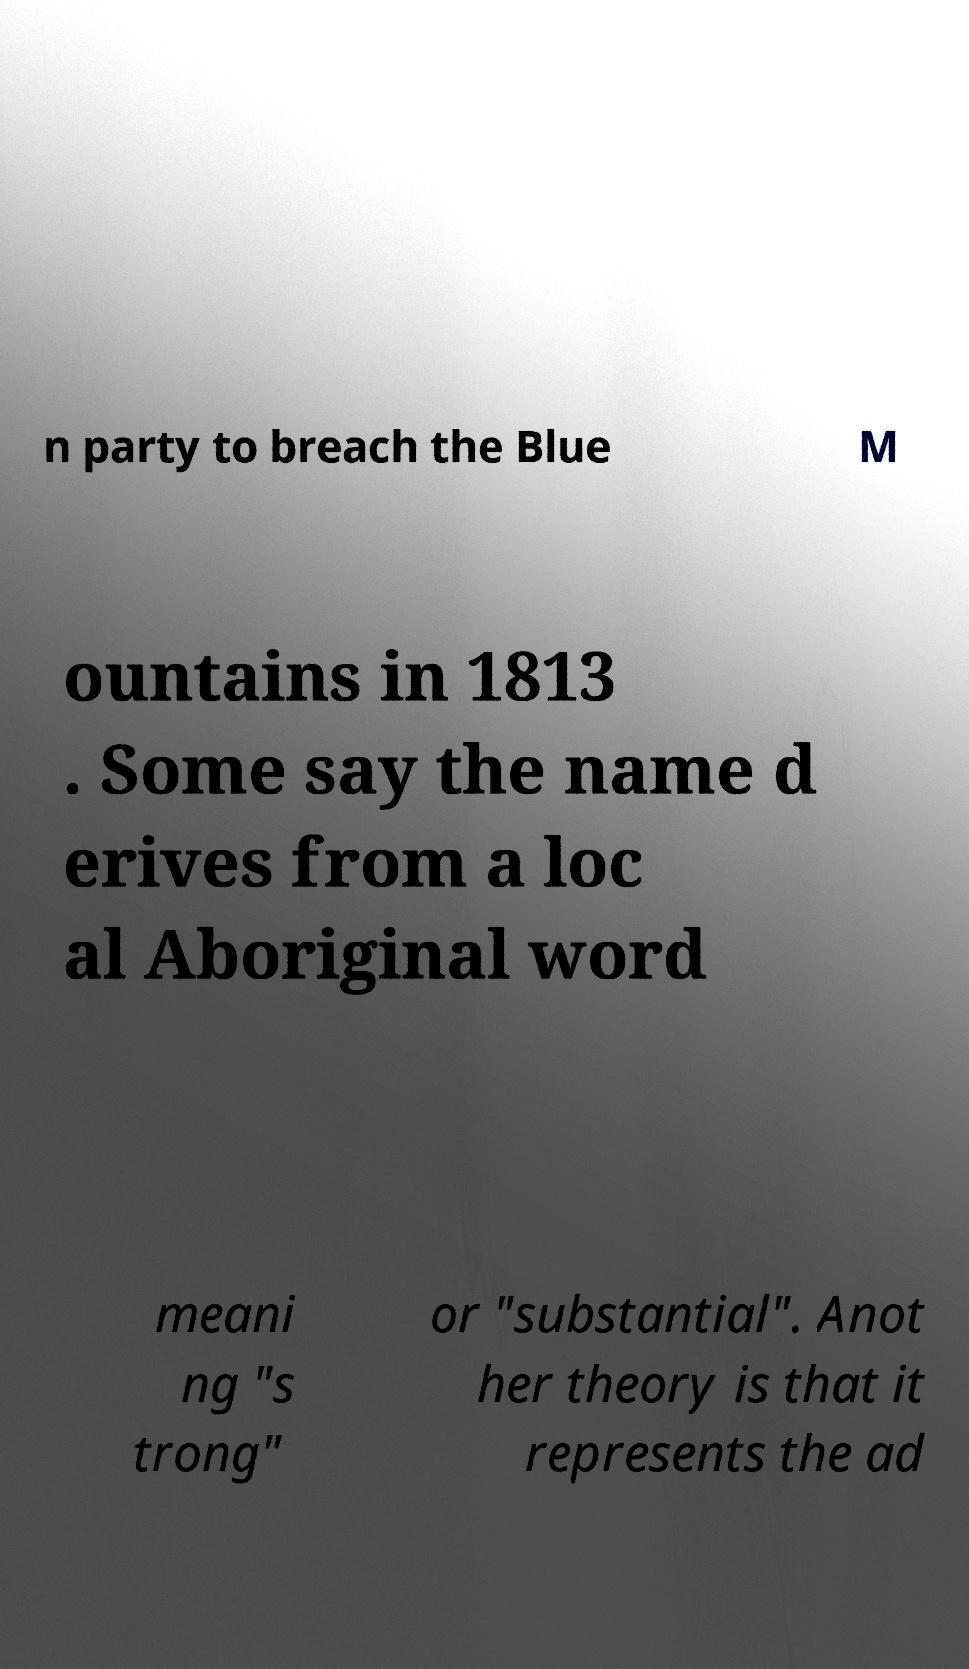Please identify and transcribe the text found in this image. n party to breach the Blue M ountains in 1813 . Some say the name d erives from a loc al Aboriginal word meani ng "s trong" or "substantial". Anot her theory is that it represents the ad 